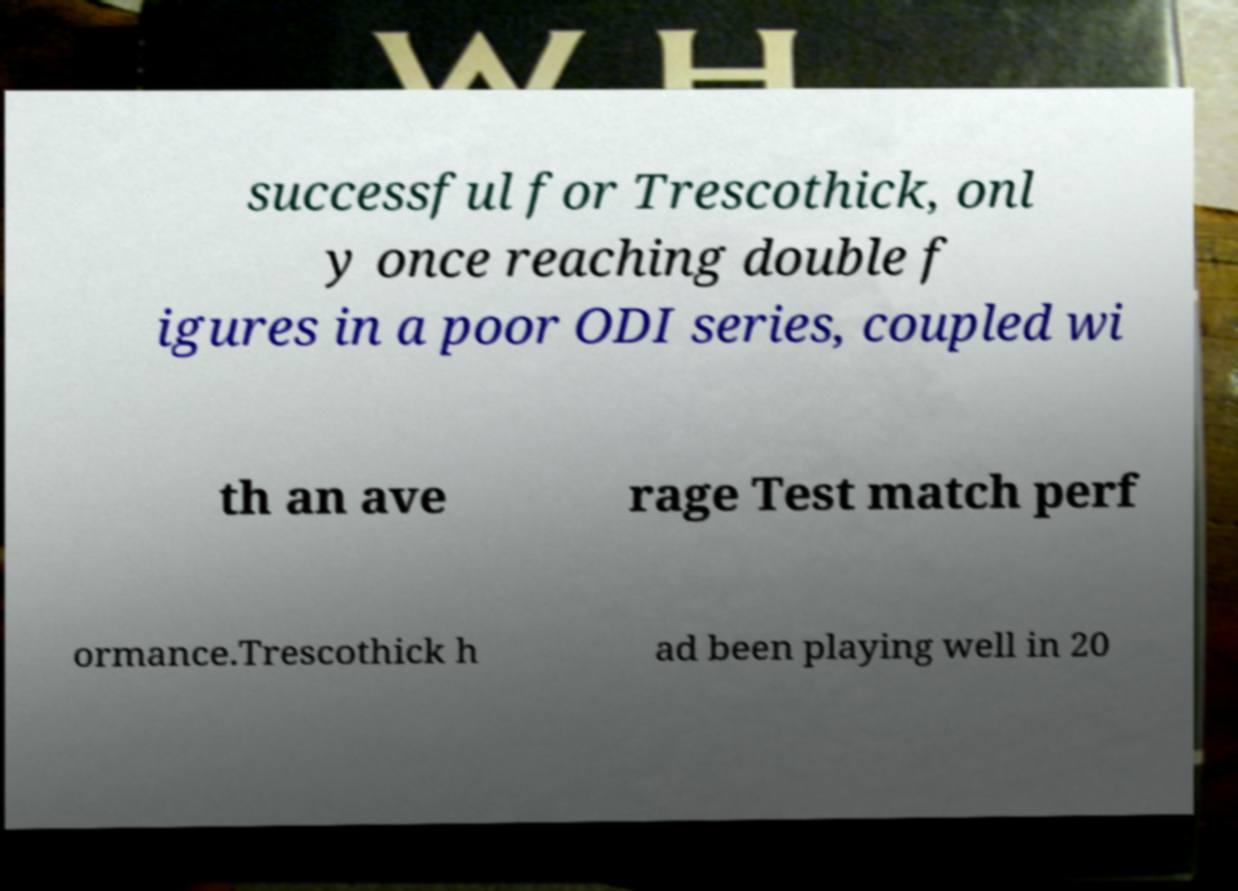For documentation purposes, I need the text within this image transcribed. Could you provide that? successful for Trescothick, onl y once reaching double f igures in a poor ODI series, coupled wi th an ave rage Test match perf ormance.Trescothick h ad been playing well in 20 